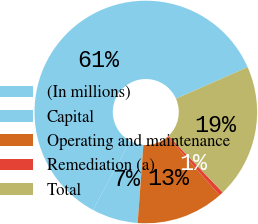Convert chart to OTSL. <chart><loc_0><loc_0><loc_500><loc_500><pie_chart><fcel>(In millions)<fcel>Capital<fcel>Operating and maintenance<fcel>Remediation (a)<fcel>Total<nl><fcel>60.52%<fcel>6.71%<fcel>12.71%<fcel>0.6%<fcel>19.45%<nl></chart> 